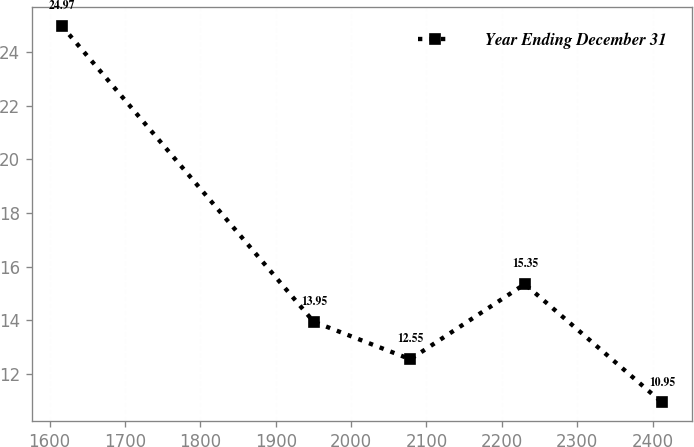<chart> <loc_0><loc_0><loc_500><loc_500><line_chart><ecel><fcel>Year Ending December 31<nl><fcel>1616.14<fcel>24.97<nl><fcel>1950.25<fcel>13.95<nl><fcel>2078.54<fcel>12.55<nl><fcel>2230.38<fcel>15.35<nl><fcel>2412.05<fcel>10.95<nl></chart> 